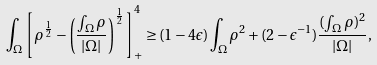Convert formula to latex. <formula><loc_0><loc_0><loc_500><loc_500>\int _ { \Omega } \left [ \rho ^ { \frac { 1 } { 2 } } - \left ( \frac { \int _ { \Omega } \rho } { | \Omega | } \right ) ^ { \frac { 1 } { 2 } } \right ] _ { + } ^ { 4 } \geq ( 1 - 4 \epsilon ) \int _ { \Omega } \rho ^ { 2 } + ( 2 - \epsilon ^ { - 1 } ) \frac { ( \int _ { \Omega } \rho ) ^ { 2 } } { | \Omega | } ,</formula> 